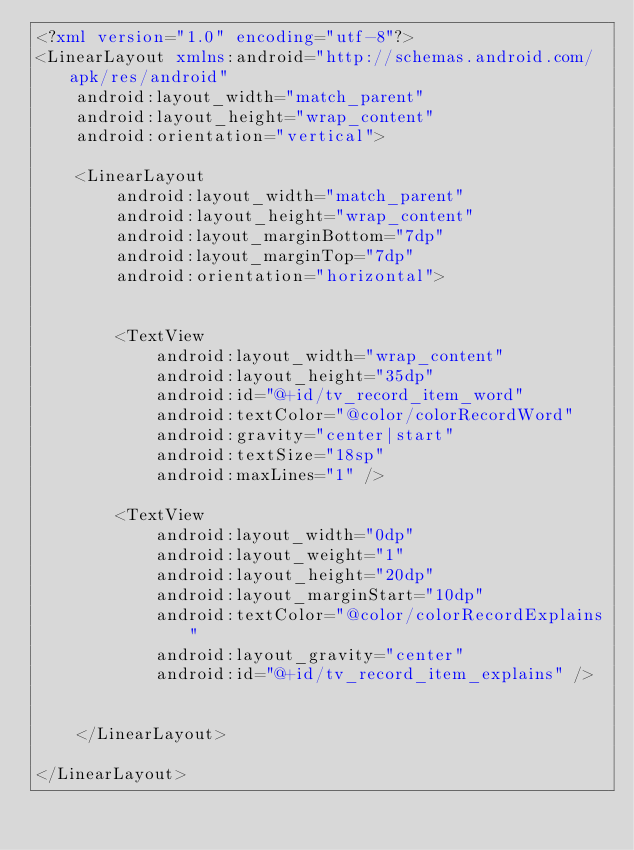Convert code to text. <code><loc_0><loc_0><loc_500><loc_500><_XML_><?xml version="1.0" encoding="utf-8"?>
<LinearLayout xmlns:android="http://schemas.android.com/apk/res/android"
    android:layout_width="match_parent"
    android:layout_height="wrap_content"
    android:orientation="vertical">

    <LinearLayout
        android:layout_width="match_parent"
        android:layout_height="wrap_content"
        android:layout_marginBottom="7dp"
        android:layout_marginTop="7dp"
        android:orientation="horizontal">


        <TextView
            android:layout_width="wrap_content"
            android:layout_height="35dp"
            android:id="@+id/tv_record_item_word"
            android:textColor="@color/colorRecordWord"
            android:gravity="center|start"
            android:textSize="18sp"
            android:maxLines="1" />

        <TextView
            android:layout_width="0dp"
            android:layout_weight="1"
            android:layout_height="20dp"
            android:layout_marginStart="10dp"
            android:textColor="@color/colorRecordExplains"
            android:layout_gravity="center"
            android:id="@+id/tv_record_item_explains" />


    </LinearLayout>

</LinearLayout>
</code> 